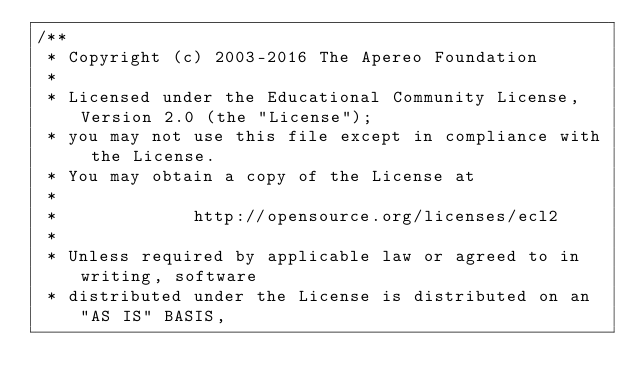<code> <loc_0><loc_0><loc_500><loc_500><_Java_>/**
 * Copyright (c) 2003-2016 The Apereo Foundation
 *
 * Licensed under the Educational Community License, Version 2.0 (the "License");
 * you may not use this file except in compliance with the License.
 * You may obtain a copy of the License at
 *
 *             http://opensource.org/licenses/ecl2
 *
 * Unless required by applicable law or agreed to in writing, software
 * distributed under the License is distributed on an "AS IS" BASIS,</code> 